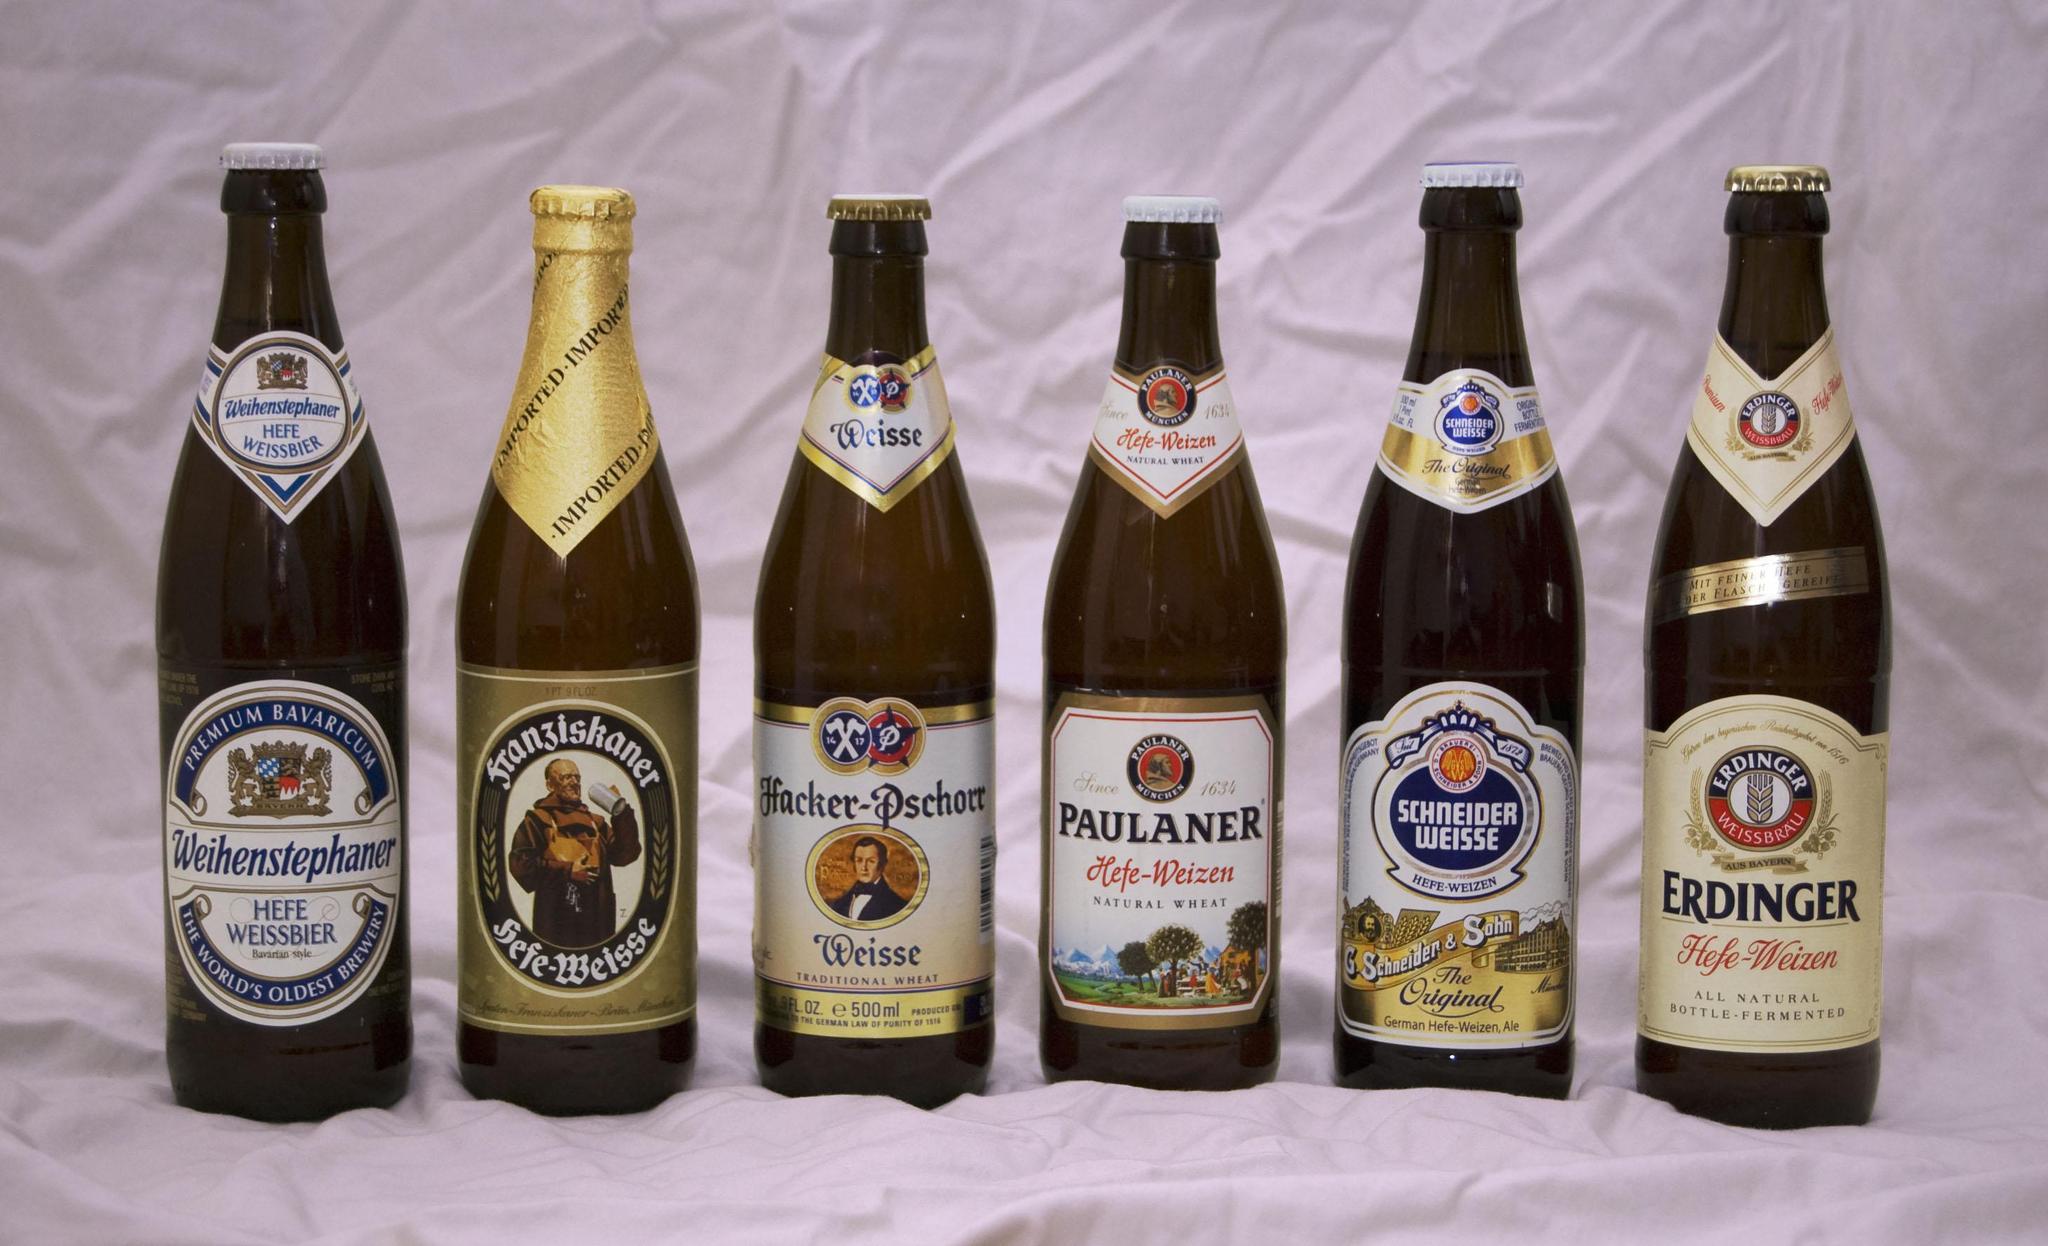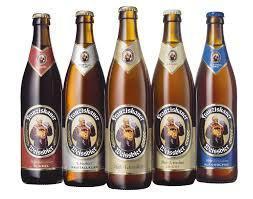The first image is the image on the left, the second image is the image on the right. Evaluate the accuracy of this statement regarding the images: "The left image contains both a bottle and a glass.". Is it true? Answer yes or no. No. The first image is the image on the left, the second image is the image on the right. Assess this claim about the two images: "In one image, a glass of ale is sitting next to a bottle of ale.". Correct or not? Answer yes or no. No. 